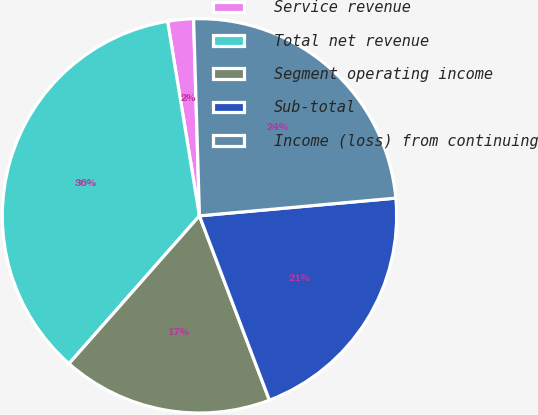Convert chart to OTSL. <chart><loc_0><loc_0><loc_500><loc_500><pie_chart><fcel>Service revenue<fcel>Total net revenue<fcel>Segment operating income<fcel>Sub-total<fcel>Income (loss) from continuing<nl><fcel>2.11%<fcel>35.91%<fcel>17.28%<fcel>20.66%<fcel>24.04%<nl></chart> 